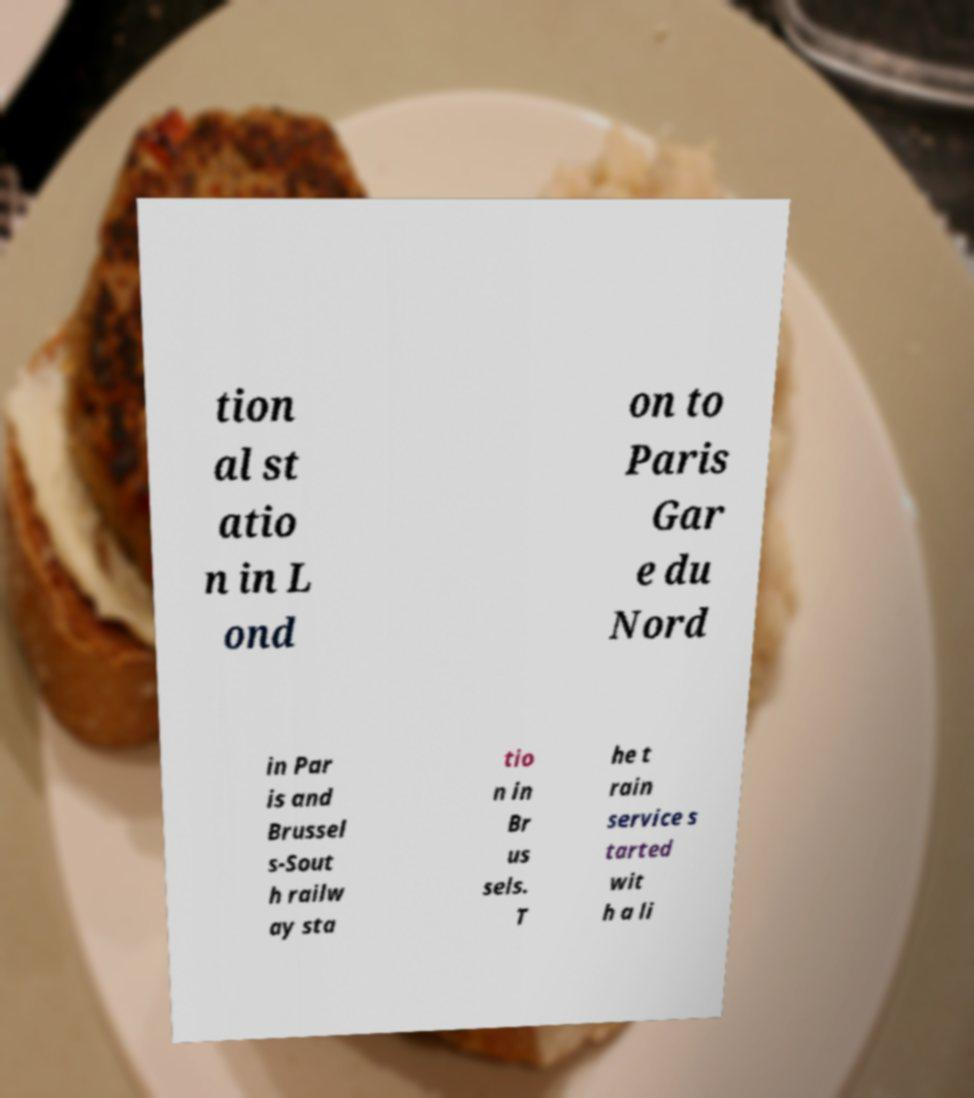I need the written content from this picture converted into text. Can you do that? tion al st atio n in L ond on to Paris Gar e du Nord in Par is and Brussel s-Sout h railw ay sta tio n in Br us sels. T he t rain service s tarted wit h a li 